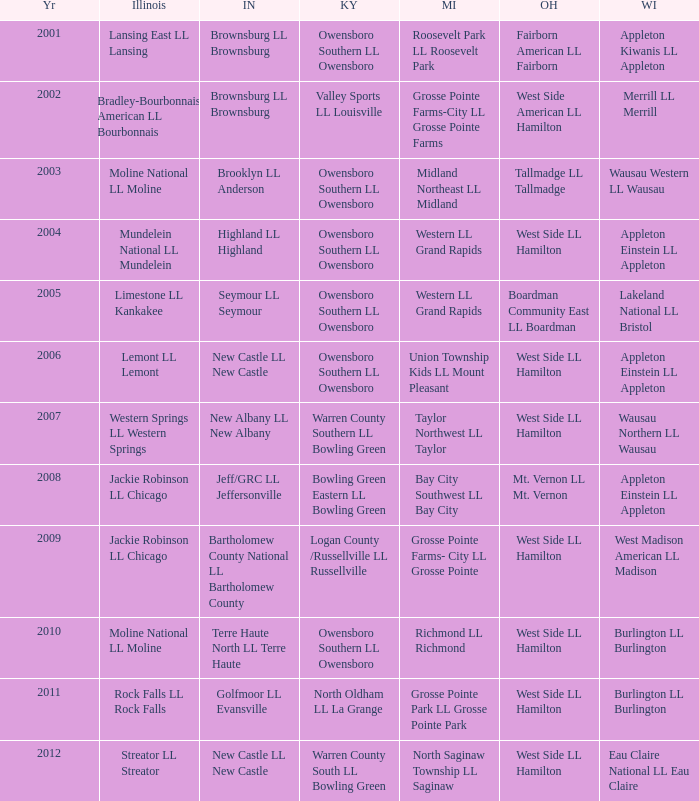What was the little league team from Kentucky when the little league team from Michigan was Grosse Pointe Farms-City LL Grosse Pointe Farms?  Valley Sports LL Louisville. 